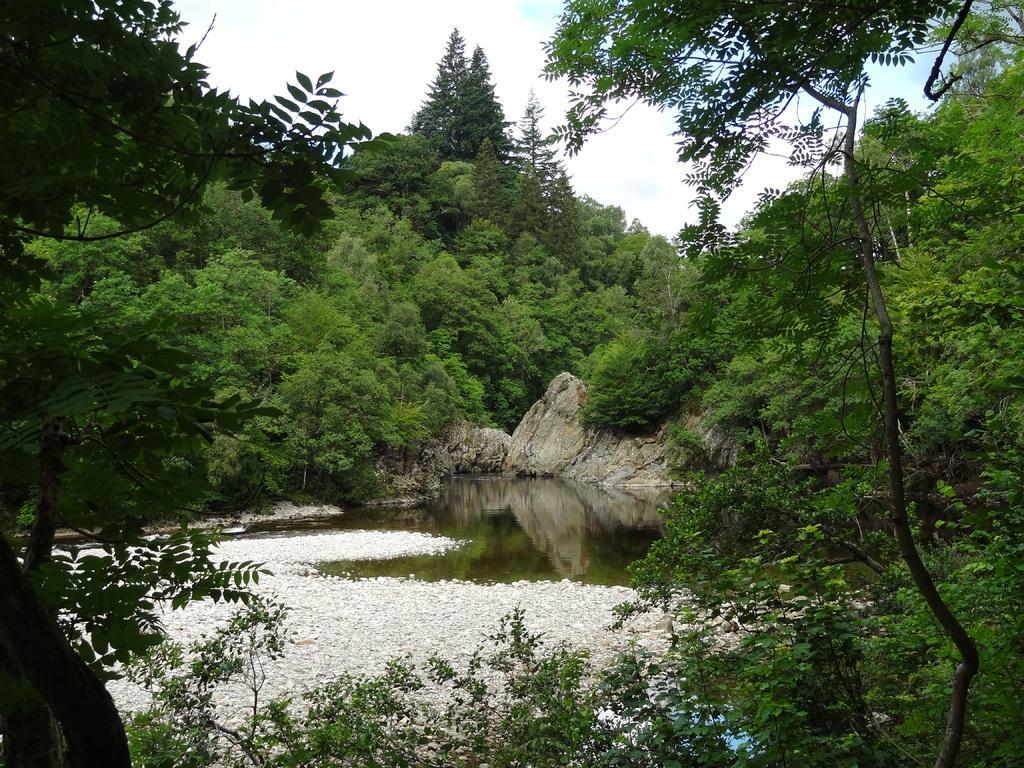Describe this image in one or two sentences. In this picture we can see water and few rocks and in the background we can see trees and the sky. 